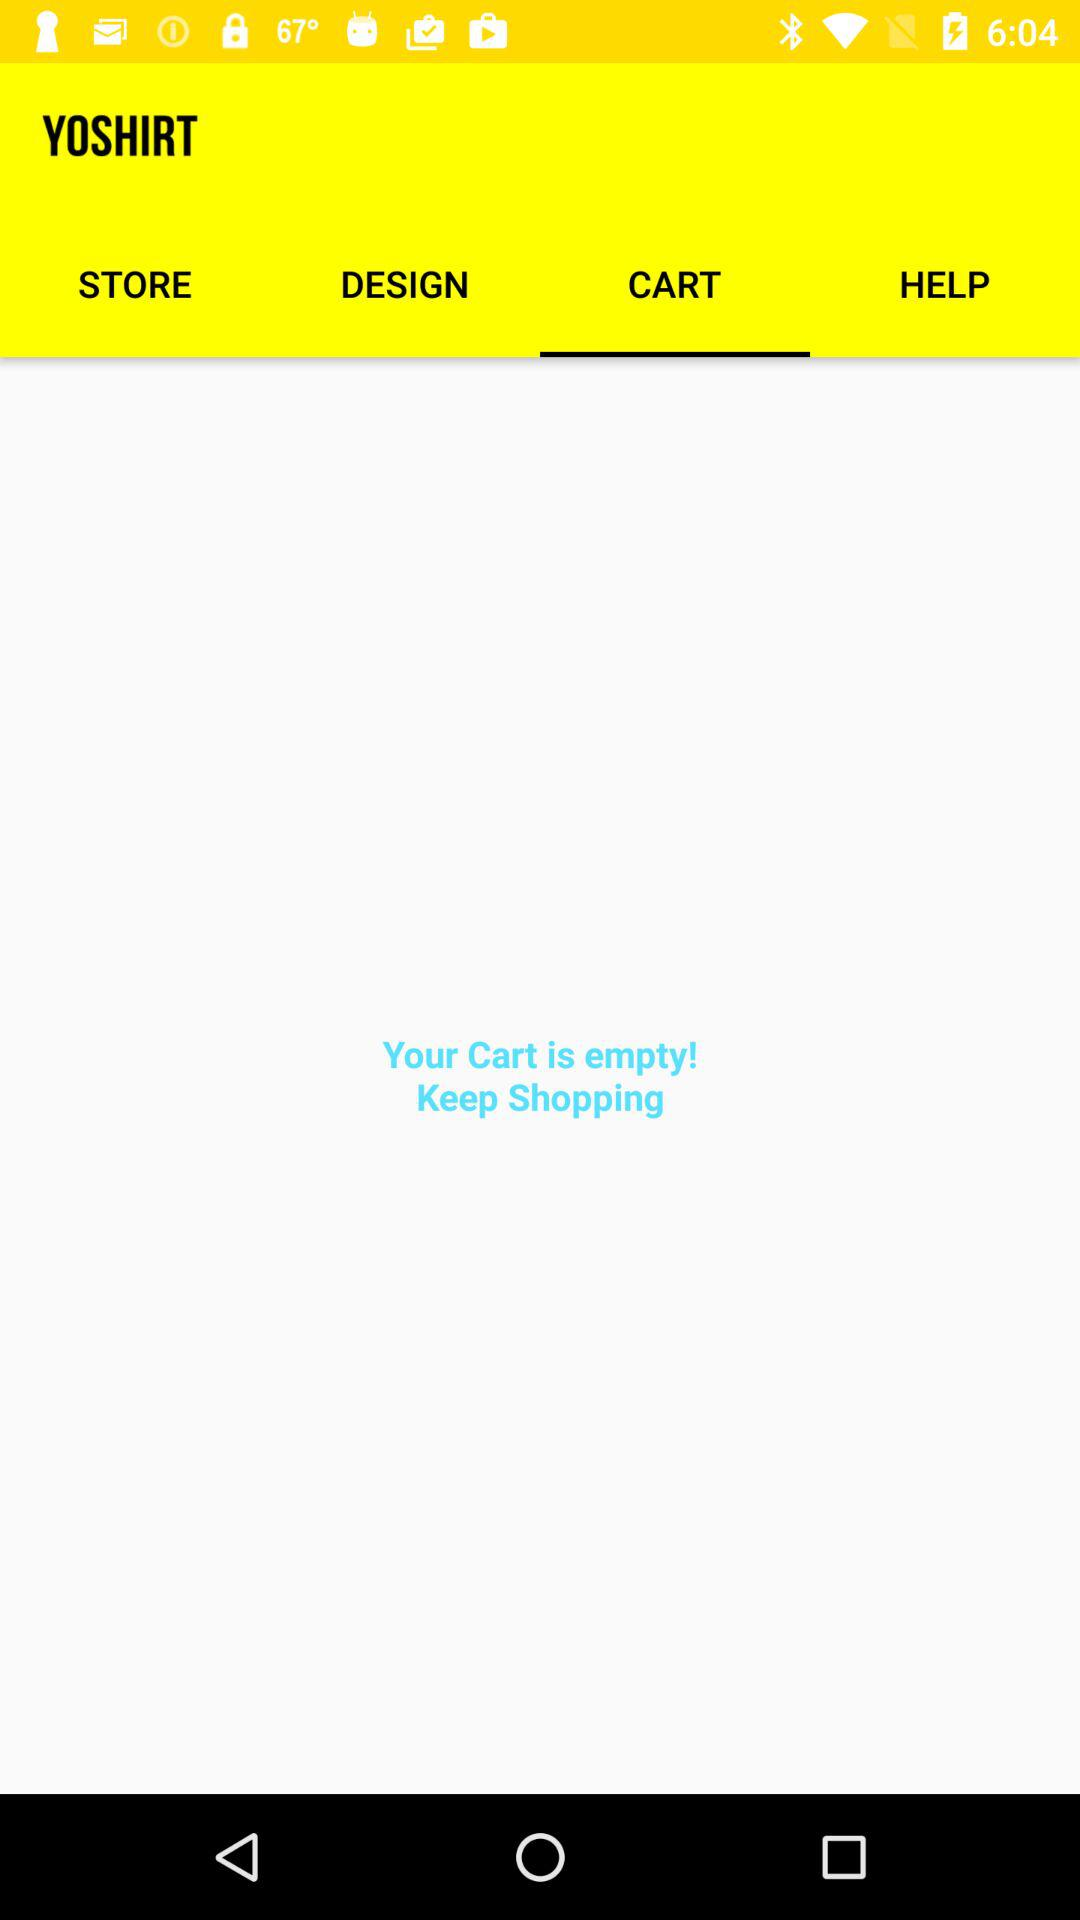How many items are in the cart? The cart is empty. 